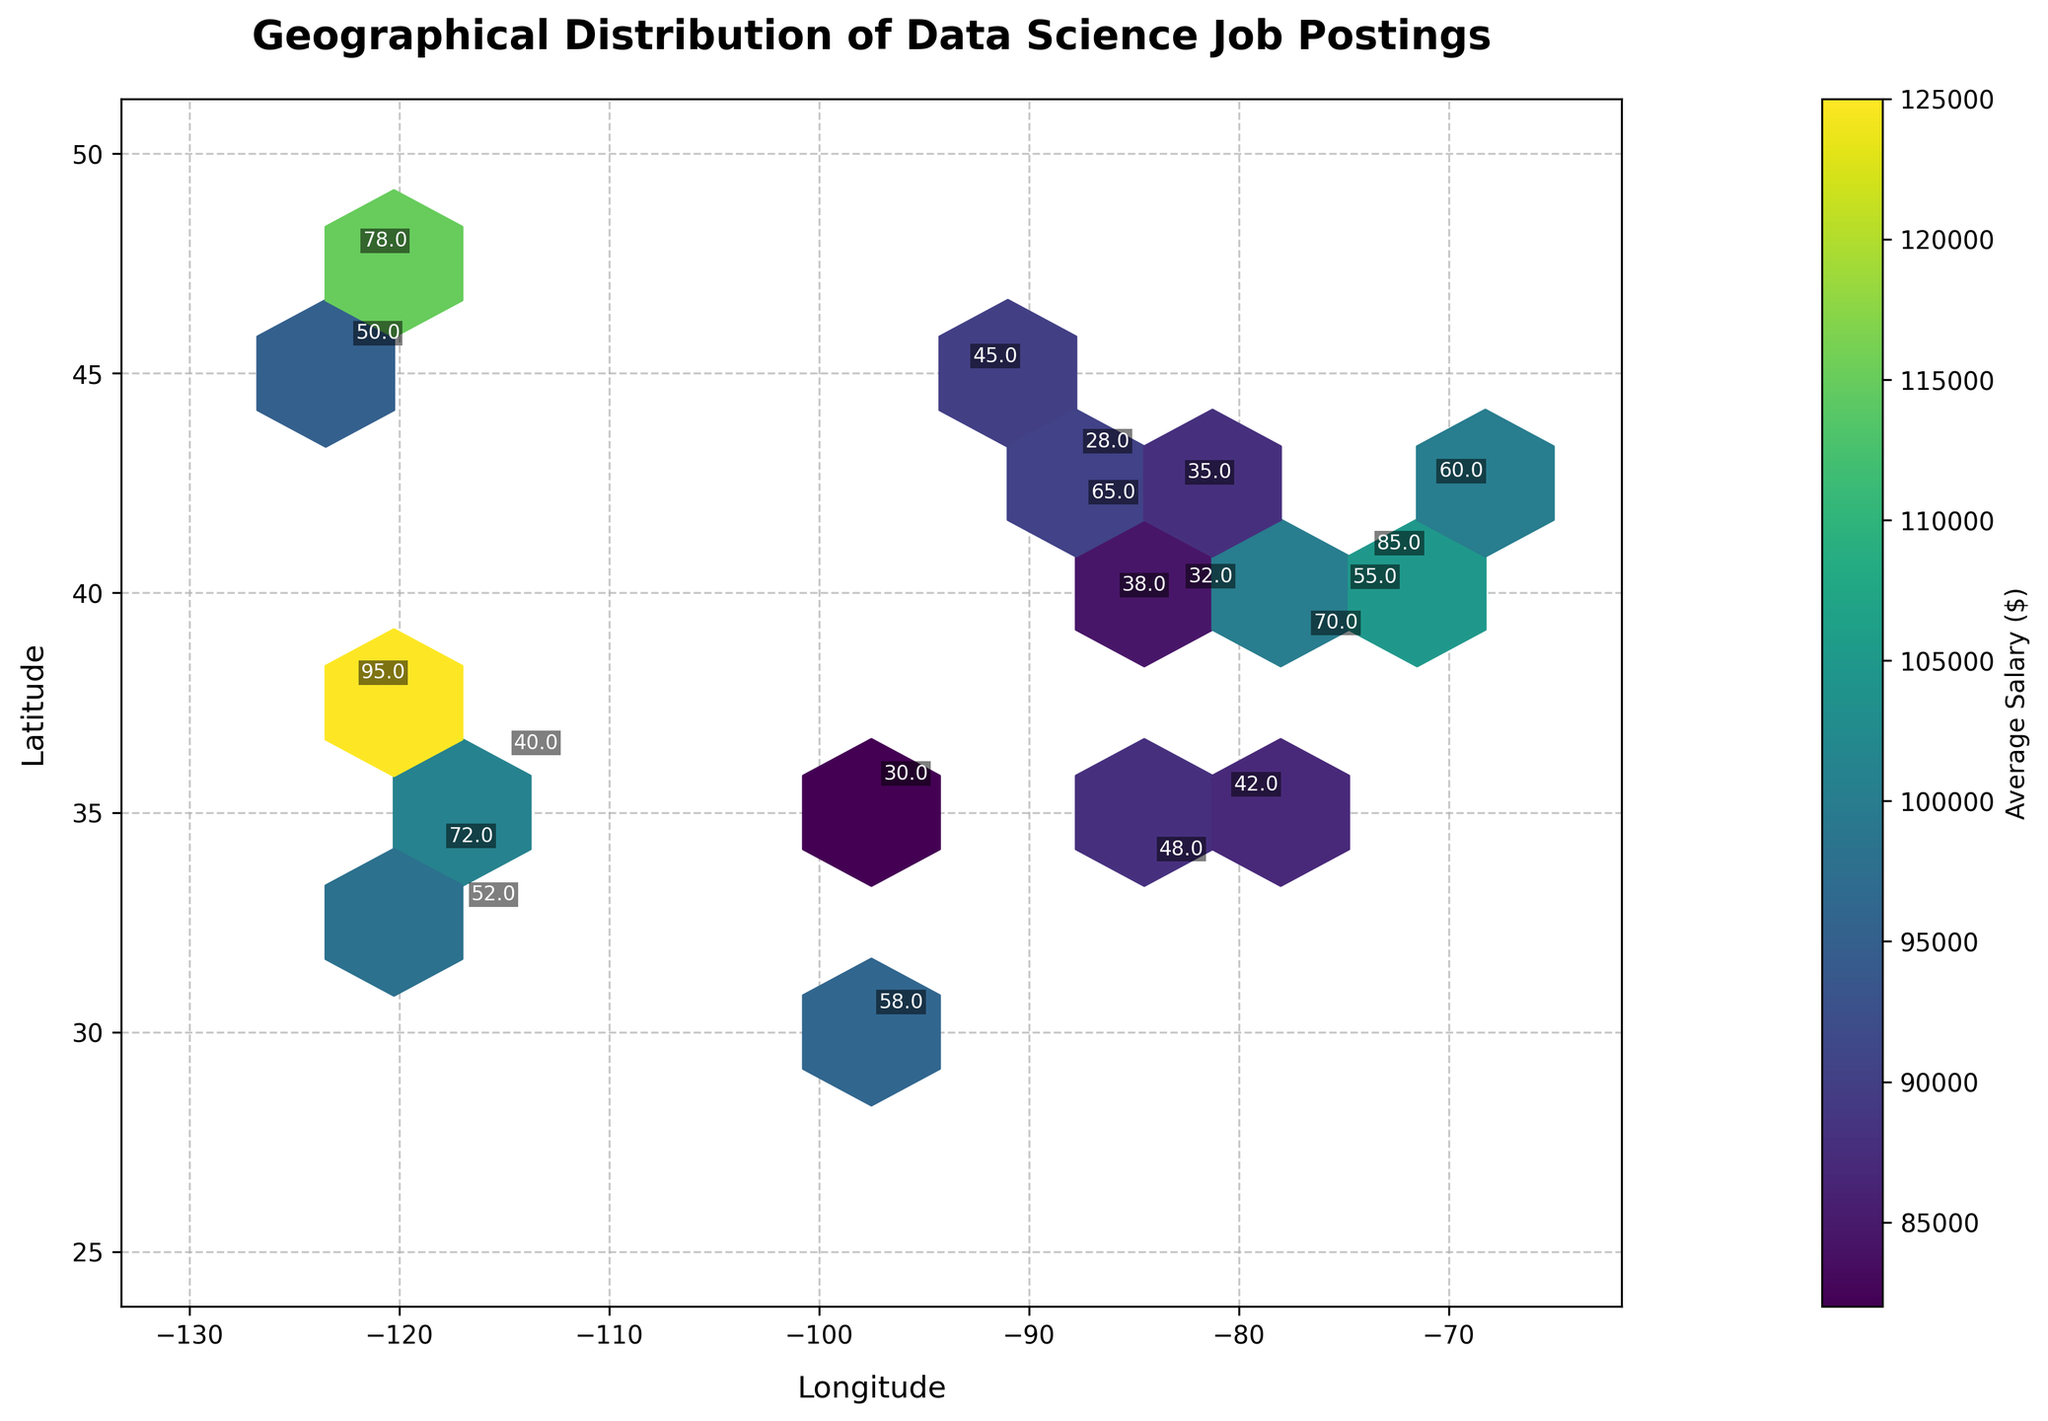What is the title of the figure? The title is typically located at the top or center of the plot.
Answer: Geographical Distribution of Data Science Job Postings What is the color label used in the plot? The color label is displayed beside the colorbar, which is usually to the side of the plot.
Answer: Average Salary ($) Which latitude and longitude have the highest number of data science job postings? Find the location with the largest annotated number on the plot.
Answer: (37.7749, -122.4194) Which city shows the highest average salary for data science job postings? Identify the hexbin with the highest color intensity on the colorbar scale and find the closest annotated city.
Answer: San Francisco (37.7749, -122.4194) How does the job count in Seattle compare to the job count in Boston? Identify the job count annotations for Seattle and Boston, then compare them. Seattle has 78 job postings, and Boston has 60.
Answer: Seattle has more job postings than Boston What area has the highest geographical concentration of data science job postings? Look for the area that has the densest clusters of hexagons.
Answer: The West Coast (around San Francisco and Seattle) What's the average job count for the cities with average salaries above $100,000? Check the cities with averages in the higher range of the colorbar and calculate their job counts. San Francisco (95), Los Angeles (72), Seattle (78), Washington D.C. (70). (95+72+78+70) / 4 = 315 / 4
Answer: 78.75 How do average salaries correlate with locations in the U.S.? Observe the distribution of colors corresponding to different salary ranges across various geographical locations.
Answer: Higher salaries are generally found on the West Coast What is the range of latitudes covered in this data? Look along the vertical axis (latitude) for the lowest and highest values represented.
Answer: 30.2672 to 47.6062 In which longitude range are most job postings found? Find the longitude range with the most hexagonal density.
Answer: -123 to -74 